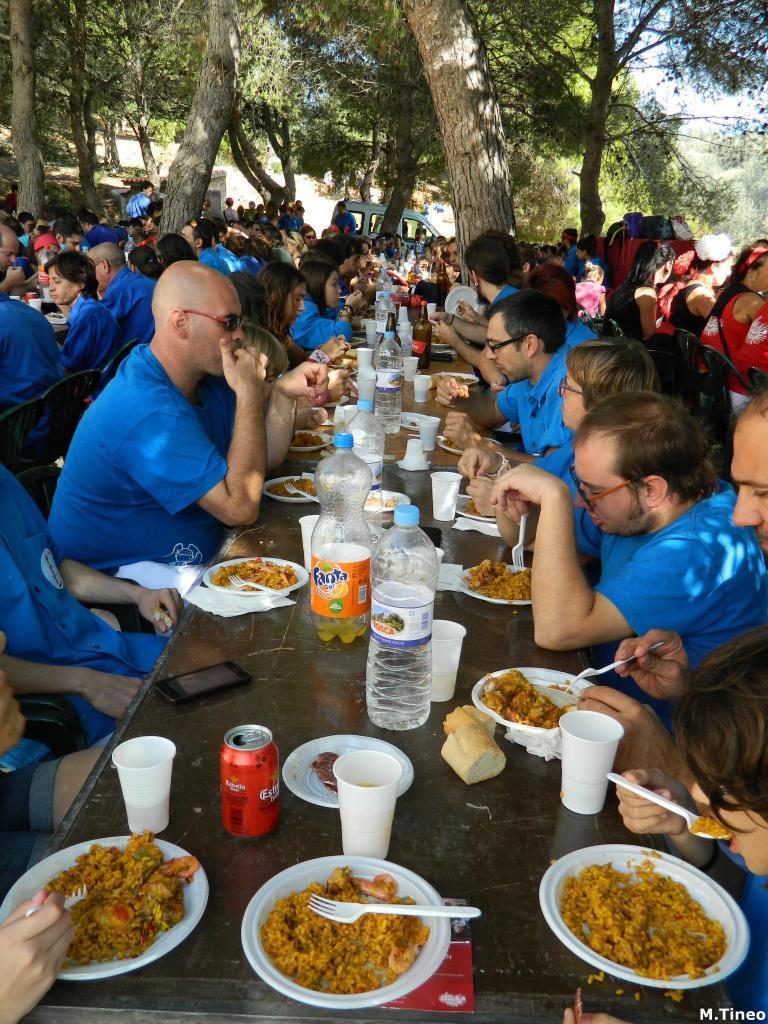Can you describe this image briefly? In this picture there are many people sitting in front of a tables and eating. All of them were in blue color t-shirts. On the table, there is a food in the plates, glasses, coke tins, Water bottles here. In the background, there are some trees and we can observe sky and clouds here. 